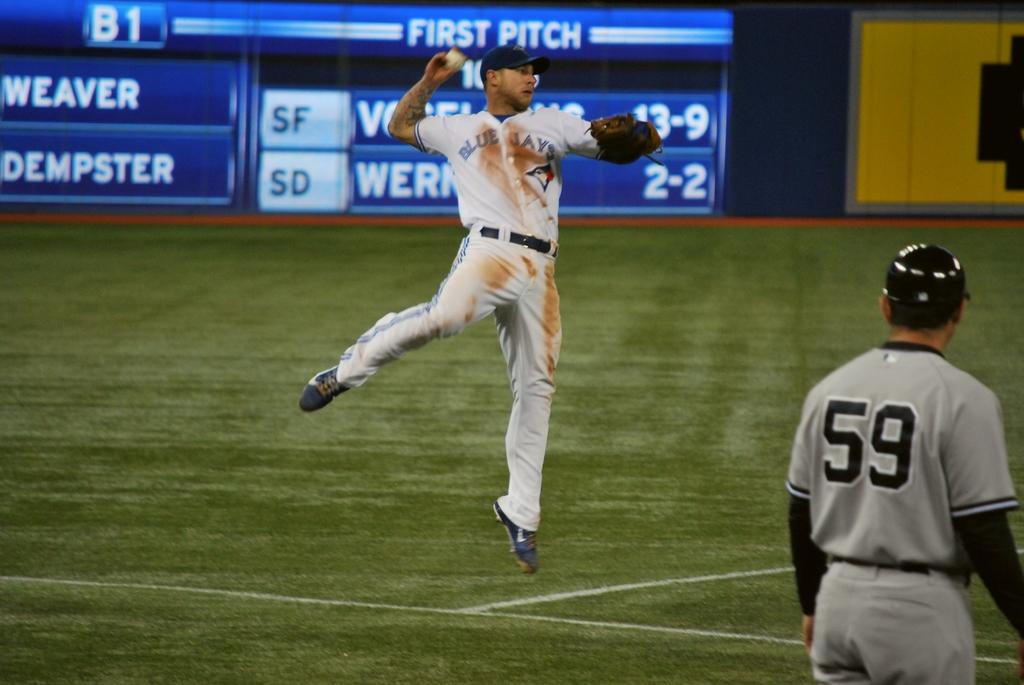What team is throwing the ball?
Keep it short and to the point. Blue jays. What is the number of the player in the foreground?
Your answer should be compact. 59. 